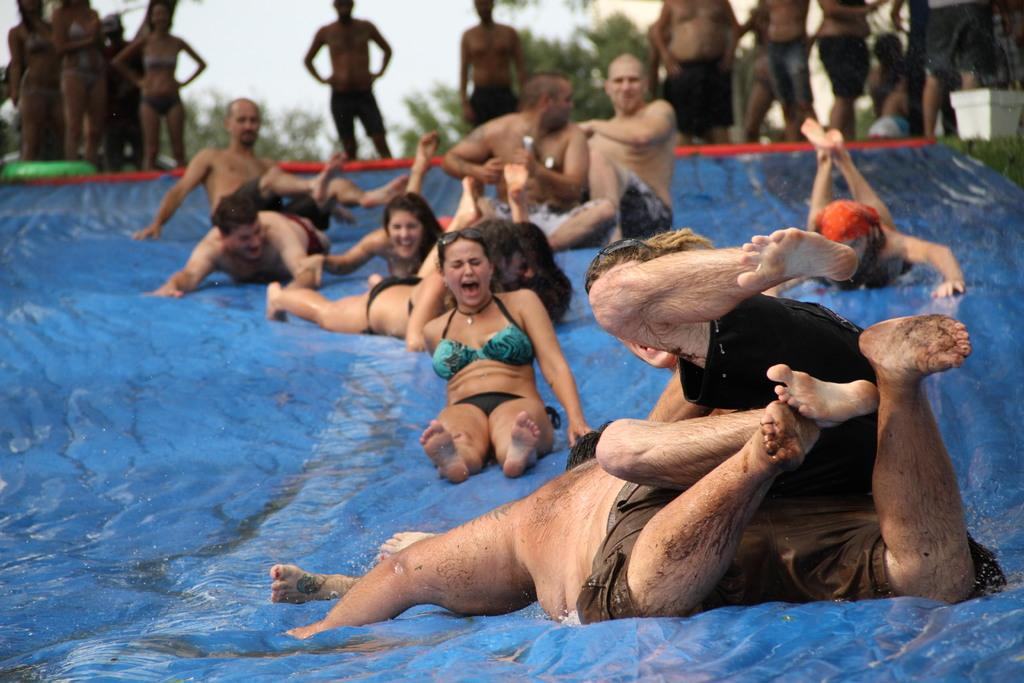What are the people in the image doing? Some people are on a water slide in the image. Can you describe the natural setting in the image? There are trees in the background of the image, and the sky is visible in the background as well. What type of company is responsible for the division of the water slide in the image? There is no company or division mentioned or depicted in the image. 